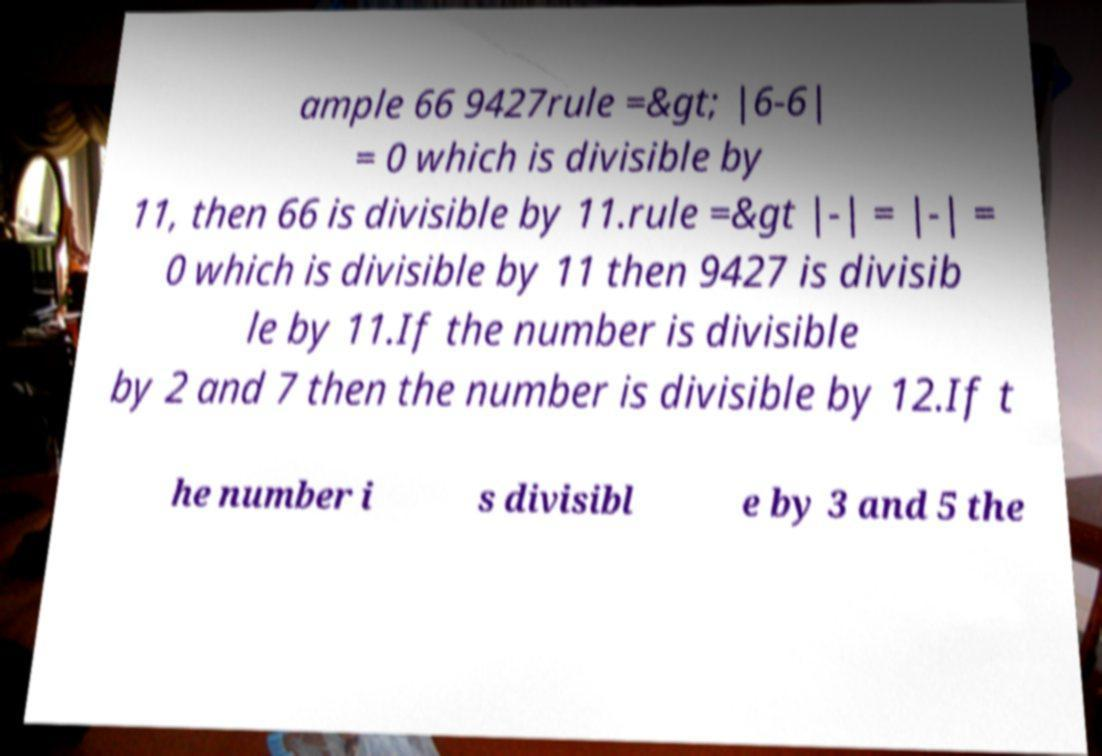I need the written content from this picture converted into text. Can you do that? ample 66 9427rule =&gt; |6-6| = 0 which is divisible by 11, then 66 is divisible by 11.rule =&gt |-| = |-| = 0 which is divisible by 11 then 9427 is divisib le by 11.If the number is divisible by 2 and 7 then the number is divisible by 12.If t he number i s divisibl e by 3 and 5 the 